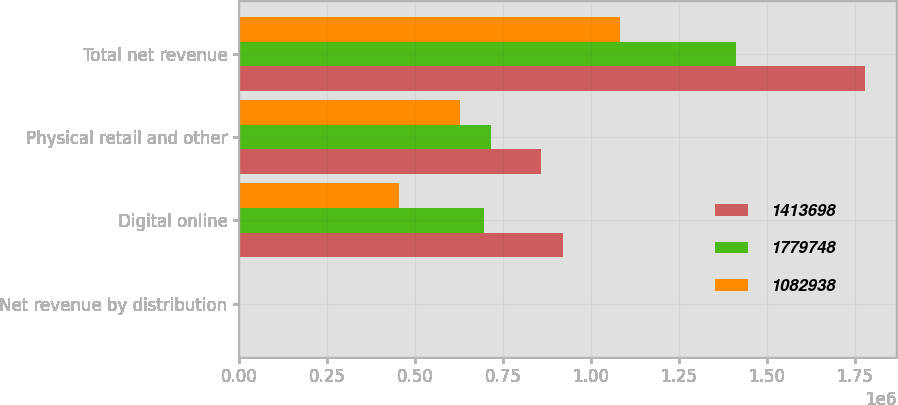<chart> <loc_0><loc_0><loc_500><loc_500><stacked_bar_chart><ecel><fcel>Net revenue by distribution<fcel>Digital online<fcel>Physical retail and other<fcel>Total net revenue<nl><fcel>1.4137e+06<fcel>2017<fcel>921734<fcel>858014<fcel>1.77975e+06<nl><fcel>1.77975e+06<fcel>2016<fcel>697658<fcel>716040<fcel>1.4137e+06<nl><fcel>1.08294e+06<fcel>2015<fcel>455299<fcel>627639<fcel>1.08294e+06<nl></chart> 